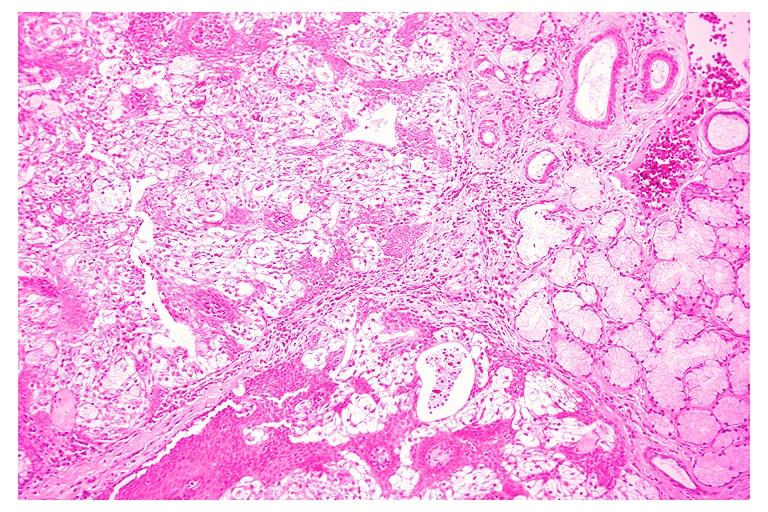where is this?
Answer the question using a single word or phrase. Oral 